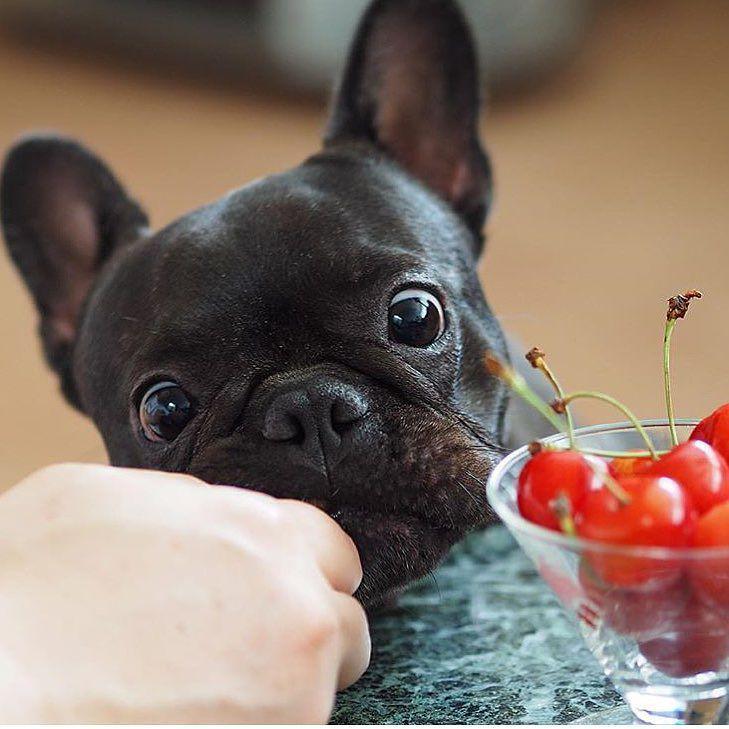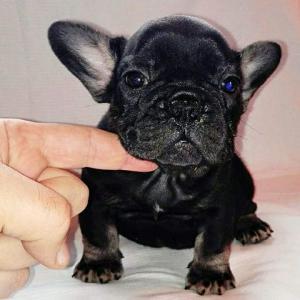The first image is the image on the left, the second image is the image on the right. Assess this claim about the two images: "The head of a dark big-eared dog is behind a container of fresh red fruit.". Correct or not? Answer yes or no. Yes. The first image is the image on the left, the second image is the image on the right. Considering the images on both sides, is "There is a serving of fresh fruit in front of a black puppy." valid? Answer yes or no. Yes. 